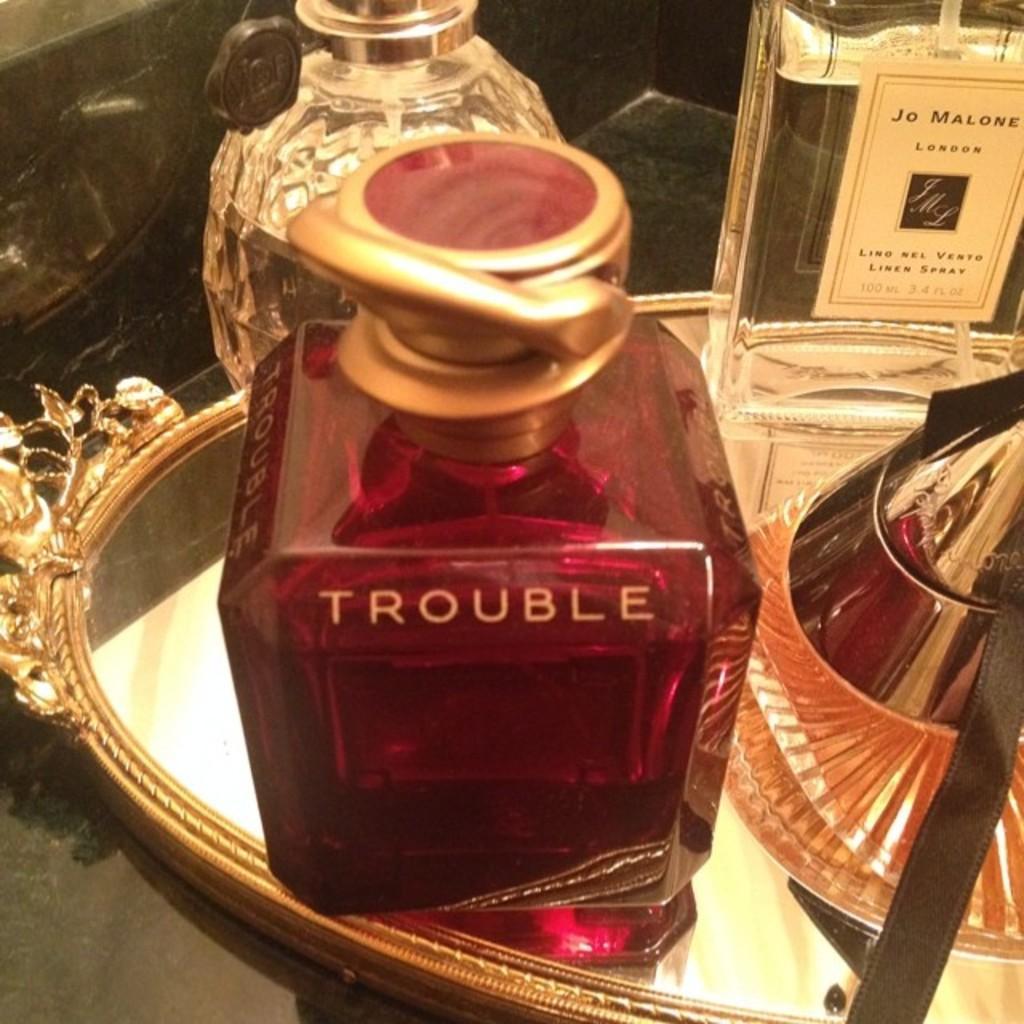Can you describe this image briefly? In the image there are few wine bottles in a tray on a table. 